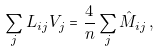Convert formula to latex. <formula><loc_0><loc_0><loc_500><loc_500>\sum _ { j } L _ { i j } V _ { j } = \frac { 4 } { n } \sum _ { j } \hat { M } _ { i j } \, ,</formula> 